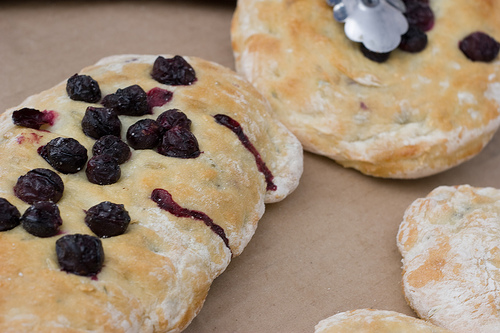<image>
Is there a food on the table? Yes. Looking at the image, I can see the food is positioned on top of the table, with the table providing support. 